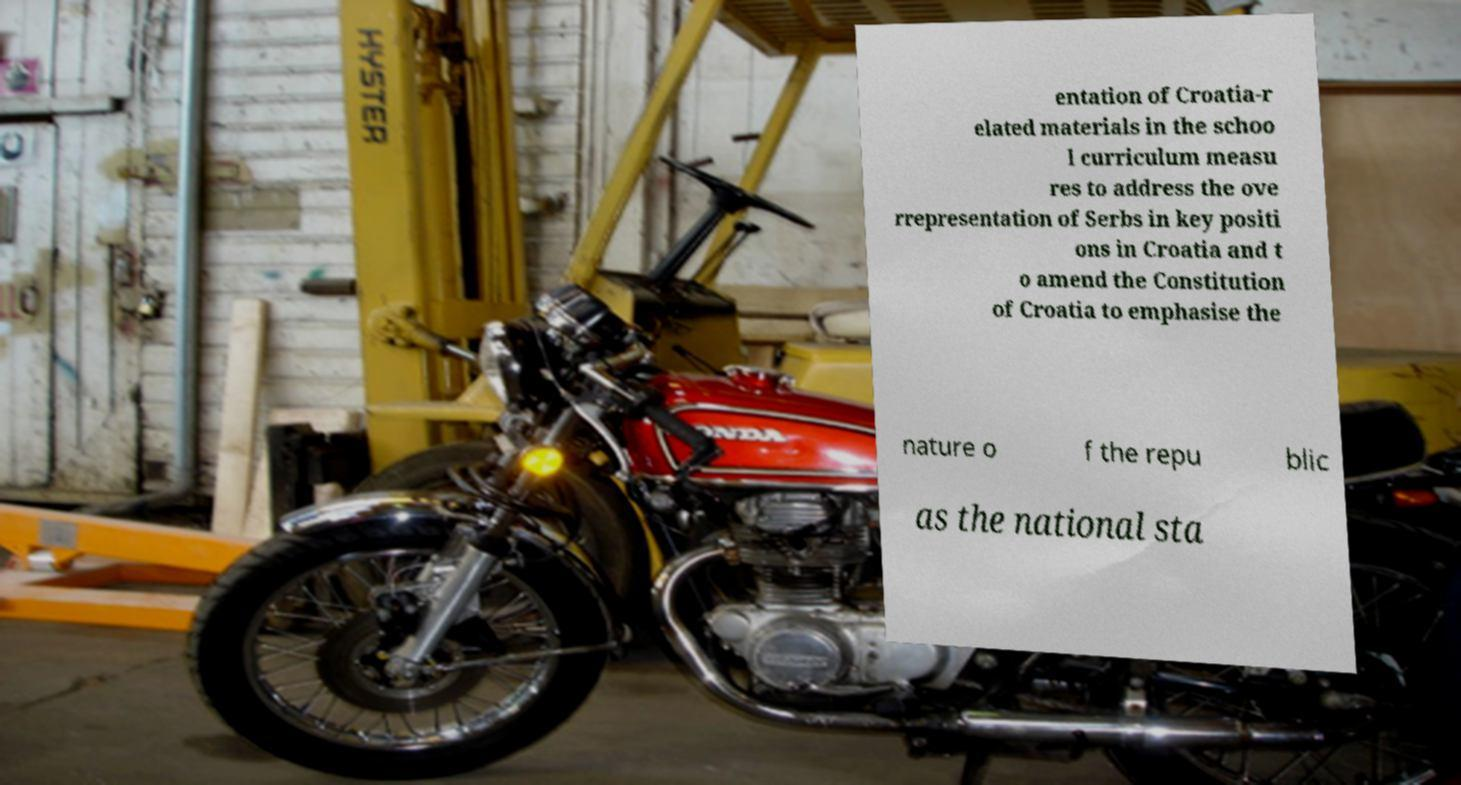There's text embedded in this image that I need extracted. Can you transcribe it verbatim? entation of Croatia-r elated materials in the schoo l curriculum measu res to address the ove rrepresentation of Serbs in key positi ons in Croatia and t o amend the Constitution of Croatia to emphasise the nature o f the repu blic as the national sta 